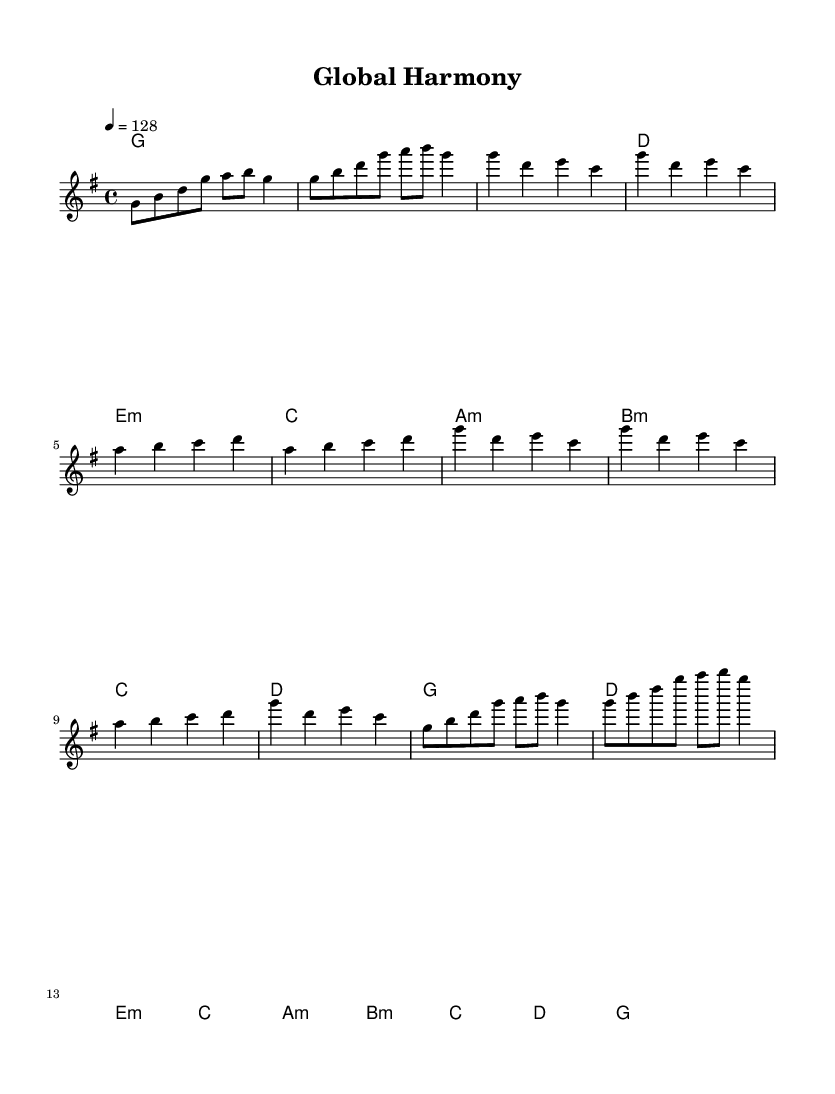What is the key signature of this music? The key signature is G major, which has one sharp (F#). This can be determined by identifying the key indicated at the beginning of the score.
Answer: G major What is the time signature of this music? The time signature is 4/4, indicated at the beginning of the score. This means there are four beats in a measure, and each quarter note gets one beat.
Answer: 4/4 What is the tempo marking for this piece? The tempo marking is 128 beats per minute, which is indicated by the "4 = 128" notation. This indicates the speed at which the piece should be played.
Answer: 128 How many measures are in the chorus section? The chorus section contains four measures. This can be counted by identifying the music notation in the chorus part of the score, which shows four complete measures.
Answer: 4 What chord follows the a minor chord in the pre-chorus? The chord that follows the a minor chord in the pre-chorus is b minor. This can be determined by looking at the chord progression notated in that section.
Answer: b minor What is the highest note in the melody? The highest note in the melody is g' (G in the octave above middle C). This is observed in the melody line when comparing the notes vertically to identify the highest pitch.
Answer: g' What section follows the intro in the music? The section that follows the intro is the verse. This is determined by analyzing the structure of the sheet music, where the intro finishes and transitions directly into the verse section.
Answer: Verse 